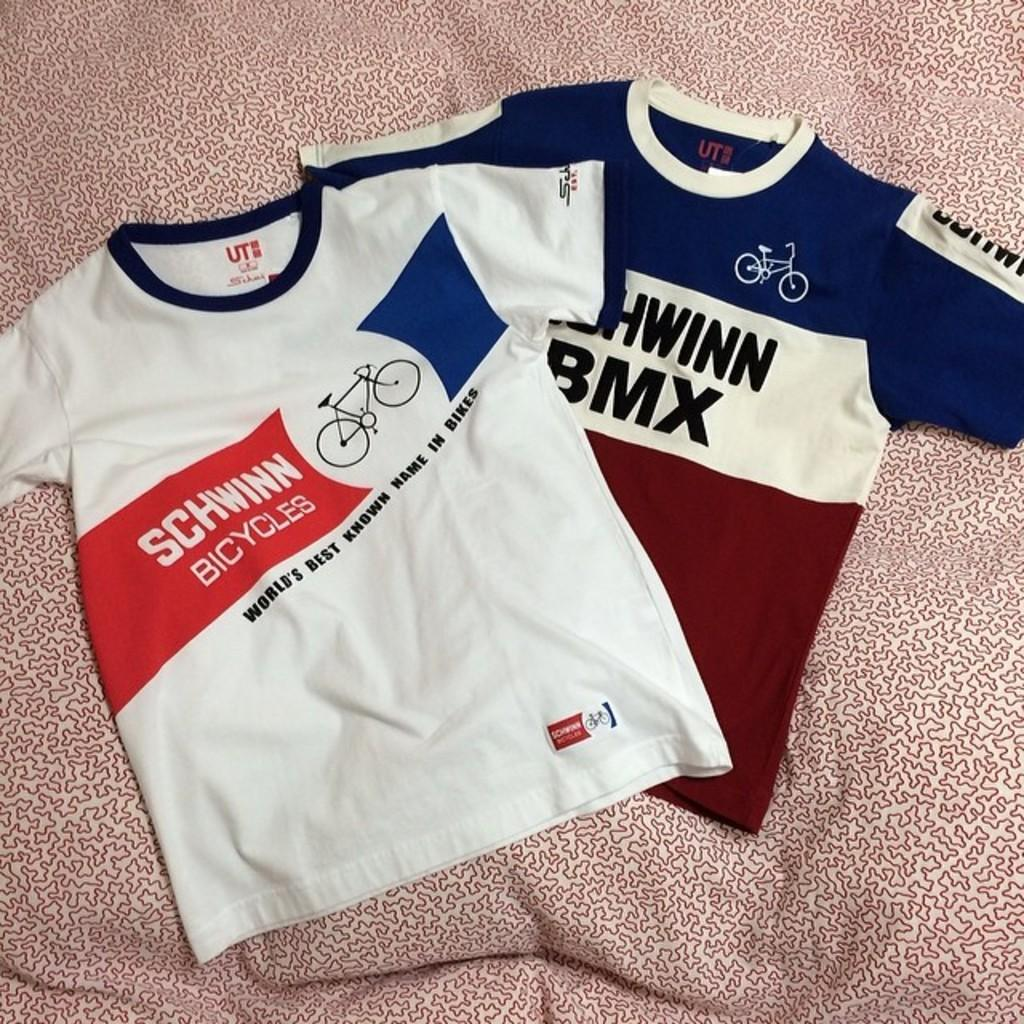How many t-shirts are visible in the image? There are two t-shirts in the image. Where are the t-shirts located? The t-shirts are on a cloth. What verse is written on the t-shirts in the image? There is no verse written on the t-shirts in the image. How many thumbs can be seen interacting with the t-shirts in the image? There is no information about thumbs or any interaction with the t-shirts in the image. 